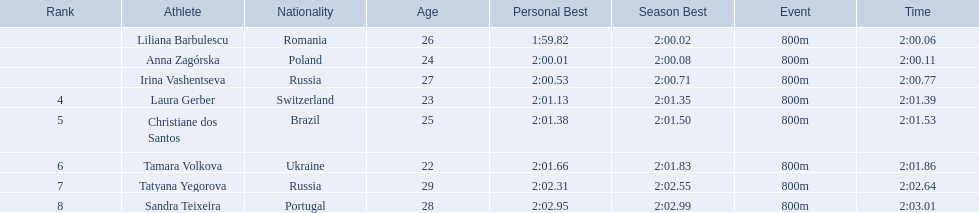Which athletes competed in the 2003 summer universiade - women's 800 metres? Liliana Barbulescu, Anna Zagórska, Irina Vashentseva, Laura Gerber, Christiane dos Santos, Tamara Volkova, Tatyana Yegorova, Sandra Teixeira. Of these, which are from poland? Anna Zagórska. What is her time? 2:00.11. 